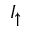<formula> <loc_0><loc_0><loc_500><loc_500>I _ { \uparrow }</formula> 